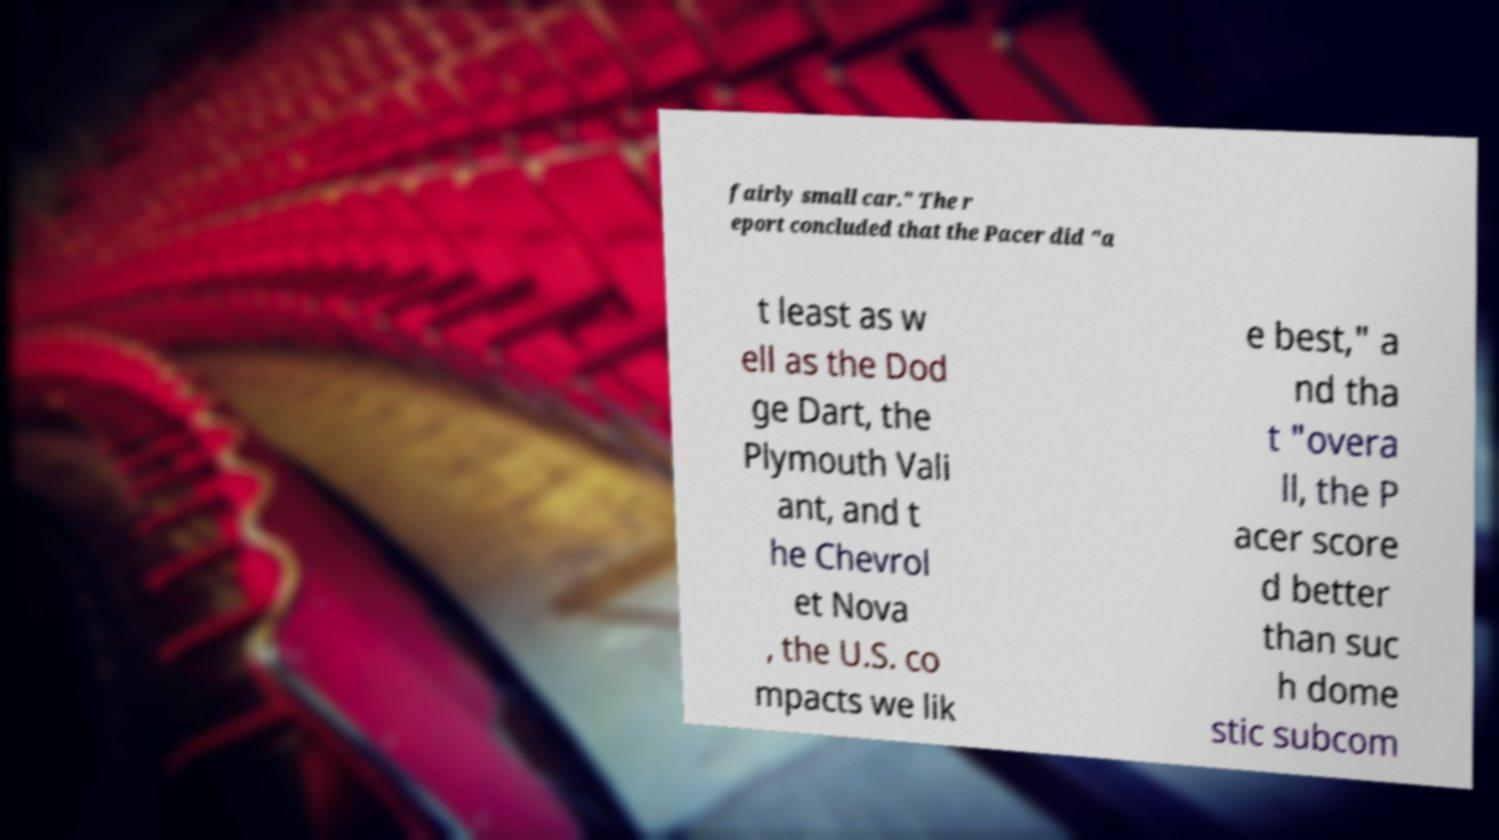For documentation purposes, I need the text within this image transcribed. Could you provide that? fairly small car." The r eport concluded that the Pacer did "a t least as w ell as the Dod ge Dart, the Plymouth Vali ant, and t he Chevrol et Nova , the U.S. co mpacts we lik e best," a nd tha t "overa ll, the P acer score d better than suc h dome stic subcom 